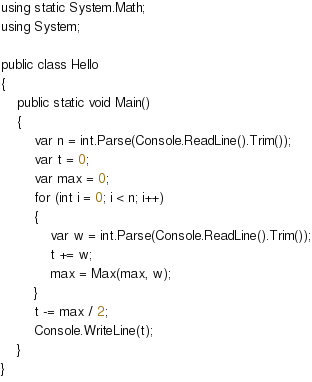<code> <loc_0><loc_0><loc_500><loc_500><_C#_>using static System.Math;
using System;

public class Hello
{
    public static void Main()
    {
        var n = int.Parse(Console.ReadLine().Trim());
        var t = 0;
        var max = 0;
        for (int i = 0; i < n; i++)
        {
            var w = int.Parse(Console.ReadLine().Trim());
            t += w;
            max = Max(max, w);
        }
        t -= max / 2;
        Console.WriteLine(t);
    }
}
</code> 